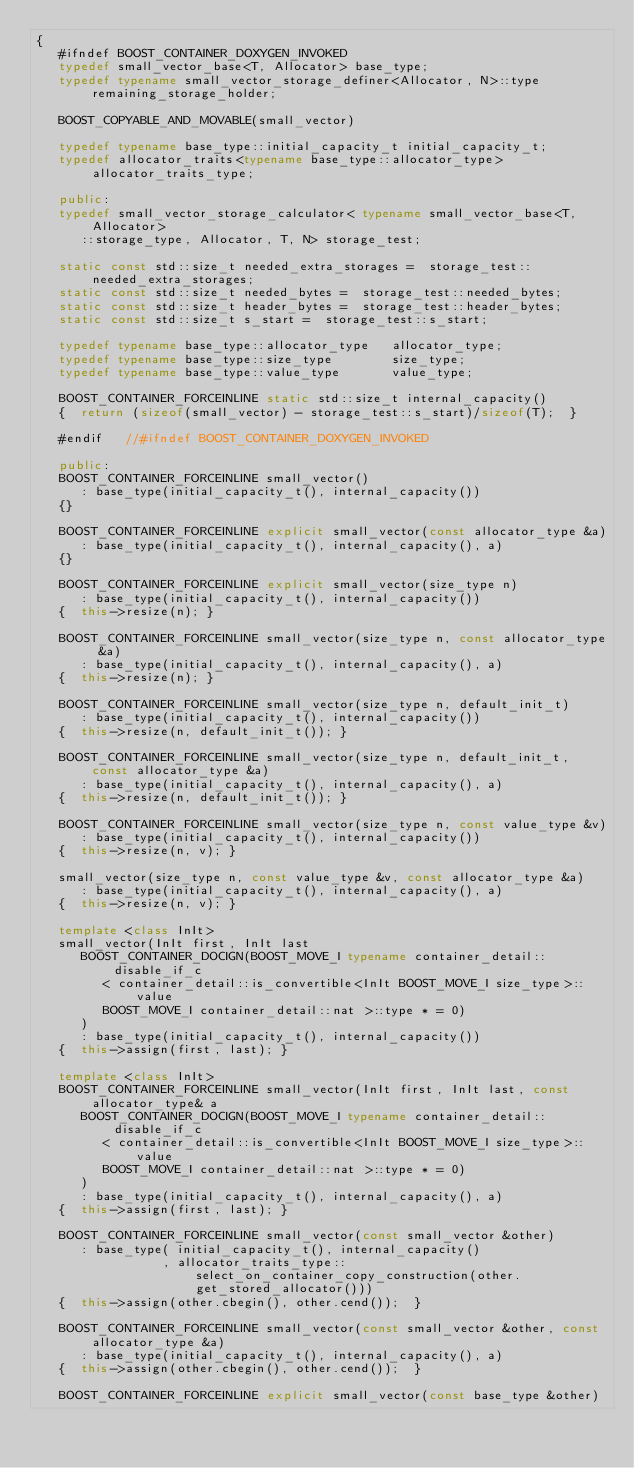Convert code to text. <code><loc_0><loc_0><loc_500><loc_500><_C++_>{
   #ifndef BOOST_CONTAINER_DOXYGEN_INVOKED
   typedef small_vector_base<T, Allocator> base_type;
   typedef typename small_vector_storage_definer<Allocator, N>::type remaining_storage_holder;

   BOOST_COPYABLE_AND_MOVABLE(small_vector)

   typedef typename base_type::initial_capacity_t initial_capacity_t;
   typedef allocator_traits<typename base_type::allocator_type> allocator_traits_type;

   public:
   typedef small_vector_storage_calculator< typename small_vector_base<T, Allocator>
      ::storage_type, Allocator, T, N> storage_test;

   static const std::size_t needed_extra_storages =  storage_test::needed_extra_storages;
   static const std::size_t needed_bytes =  storage_test::needed_bytes;
   static const std::size_t header_bytes =  storage_test::header_bytes;
   static const std::size_t s_start =  storage_test::s_start;

   typedef typename base_type::allocator_type   allocator_type;
   typedef typename base_type::size_type        size_type;
   typedef typename base_type::value_type       value_type;

   BOOST_CONTAINER_FORCEINLINE static std::size_t internal_capacity()
   {  return (sizeof(small_vector) - storage_test::s_start)/sizeof(T);  }

   #endif   //#ifndef BOOST_CONTAINER_DOXYGEN_INVOKED

   public:
   BOOST_CONTAINER_FORCEINLINE small_vector()
      : base_type(initial_capacity_t(), internal_capacity())
   {}

   BOOST_CONTAINER_FORCEINLINE explicit small_vector(const allocator_type &a)
      : base_type(initial_capacity_t(), internal_capacity(), a)
   {}

   BOOST_CONTAINER_FORCEINLINE explicit small_vector(size_type n)
      : base_type(initial_capacity_t(), internal_capacity())
   {  this->resize(n); }

   BOOST_CONTAINER_FORCEINLINE small_vector(size_type n, const allocator_type &a)
      : base_type(initial_capacity_t(), internal_capacity(), a)
   {  this->resize(n); }

   BOOST_CONTAINER_FORCEINLINE small_vector(size_type n, default_init_t)
      : base_type(initial_capacity_t(), internal_capacity())
   {  this->resize(n, default_init_t()); }

   BOOST_CONTAINER_FORCEINLINE small_vector(size_type n, default_init_t, const allocator_type &a)
      : base_type(initial_capacity_t(), internal_capacity(), a)
   {  this->resize(n, default_init_t()); }

   BOOST_CONTAINER_FORCEINLINE small_vector(size_type n, const value_type &v)
      : base_type(initial_capacity_t(), internal_capacity())
   {  this->resize(n, v); }

   small_vector(size_type n, const value_type &v, const allocator_type &a)
      : base_type(initial_capacity_t(), internal_capacity(), a)
   {  this->resize(n, v); }

   template <class InIt>
   small_vector(InIt first, InIt last
      BOOST_CONTAINER_DOCIGN(BOOST_MOVE_I typename container_detail::disable_if_c
         < container_detail::is_convertible<InIt BOOST_MOVE_I size_type>::value
         BOOST_MOVE_I container_detail::nat >::type * = 0)
      )
      : base_type(initial_capacity_t(), internal_capacity())
   {  this->assign(first, last); }

   template <class InIt>
   BOOST_CONTAINER_FORCEINLINE small_vector(InIt first, InIt last, const allocator_type& a
      BOOST_CONTAINER_DOCIGN(BOOST_MOVE_I typename container_detail::disable_if_c
         < container_detail::is_convertible<InIt BOOST_MOVE_I size_type>::value
         BOOST_MOVE_I container_detail::nat >::type * = 0)
      )
      : base_type(initial_capacity_t(), internal_capacity(), a)
   {  this->assign(first, last); }

   BOOST_CONTAINER_FORCEINLINE small_vector(const small_vector &other)
      : base_type( initial_capacity_t(), internal_capacity()
                 , allocator_traits_type::select_on_container_copy_construction(other.get_stored_allocator()))
   {  this->assign(other.cbegin(), other.cend());  }

   BOOST_CONTAINER_FORCEINLINE small_vector(const small_vector &other, const allocator_type &a)
      : base_type(initial_capacity_t(), internal_capacity(), a)
   {  this->assign(other.cbegin(), other.cend());  }

   BOOST_CONTAINER_FORCEINLINE explicit small_vector(const base_type &other)</code> 